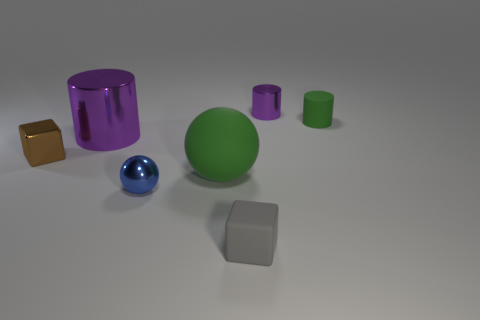Add 2 tiny matte cylinders. How many objects exist? 9 Subtract all blocks. How many objects are left? 5 Add 2 big metallic cylinders. How many big metallic cylinders exist? 3 Subtract 1 blue balls. How many objects are left? 6 Subtract all rubber cubes. Subtract all purple metal objects. How many objects are left? 4 Add 5 purple metal cylinders. How many purple metal cylinders are left? 7 